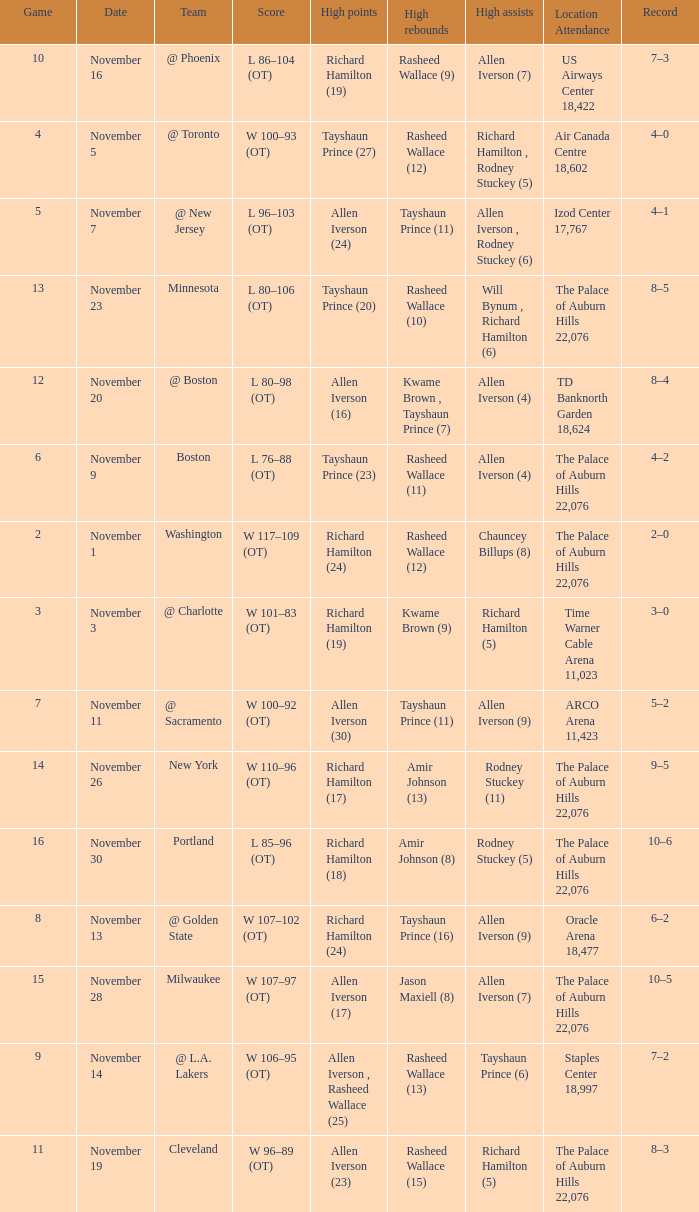What is Location Attendance, when High Points is "Allen Iverson (23)"? The Palace of Auburn Hills 22,076. 